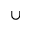<formula> <loc_0><loc_0><loc_500><loc_500>\cup</formula> 